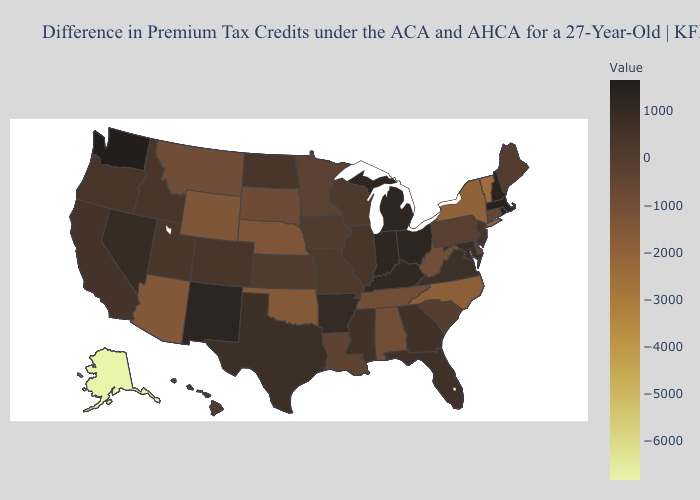Does Kansas have the highest value in the USA?
Give a very brief answer. No. Does Kentucky have the highest value in the South?
Keep it brief. Yes. Among the states that border Kansas , does Colorado have the highest value?
Short answer required. Yes. Among the states that border Iowa , does Missouri have the highest value?
Short answer required. No. Does Kentucky have the lowest value in the USA?
Give a very brief answer. No. Does South Carolina have a higher value than Indiana?
Give a very brief answer. No. Does Oklahoma have the highest value in the South?
Concise answer only. No. Which states hav the highest value in the West?
Give a very brief answer. Washington. Which states hav the highest value in the South?
Keep it brief. Kentucky. 